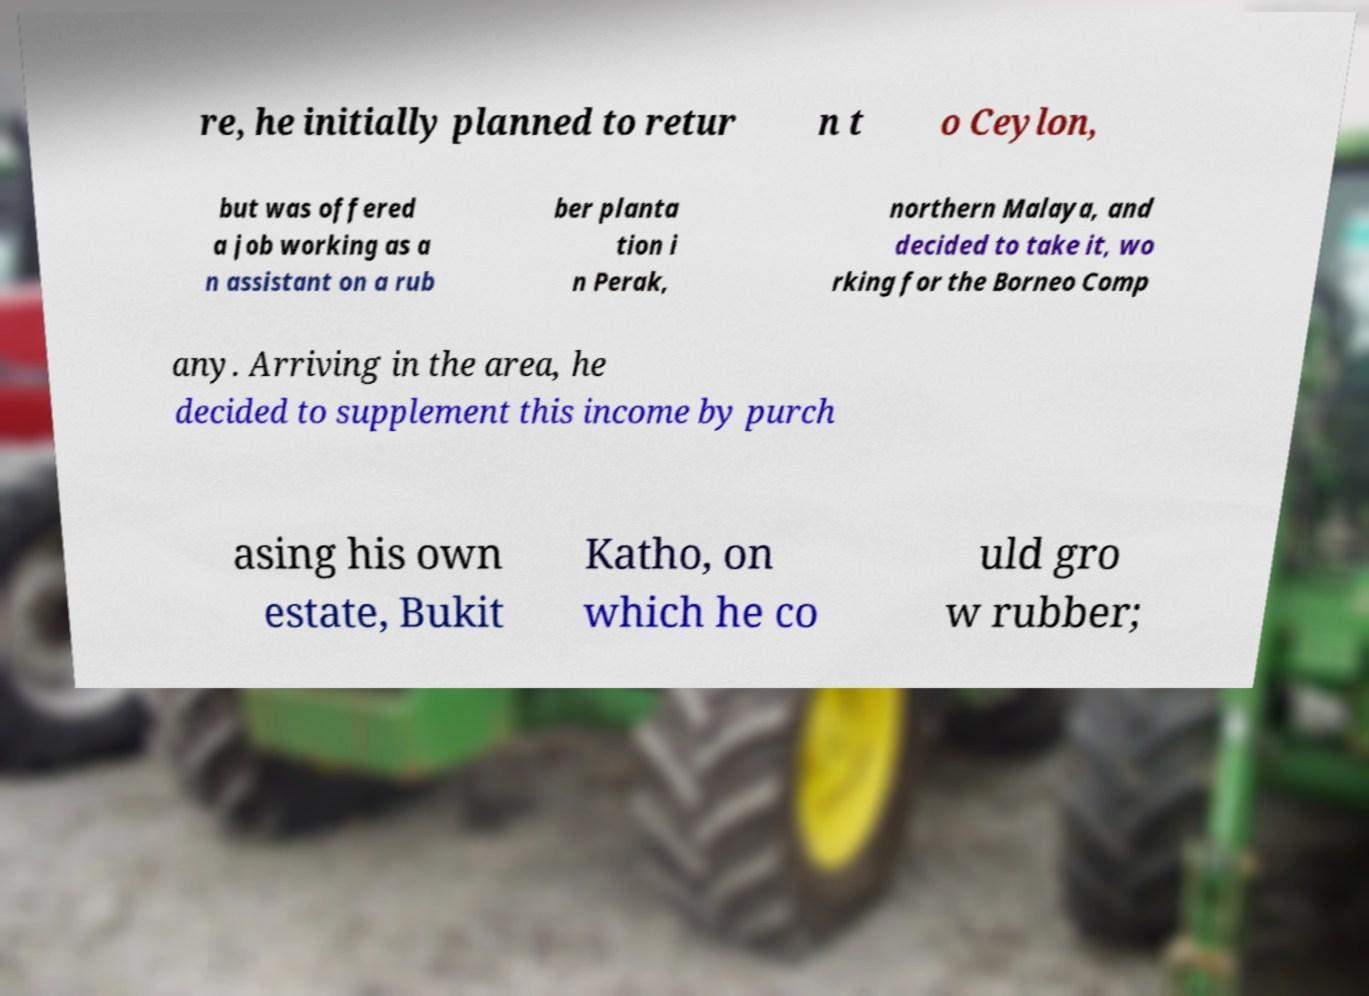Please read and relay the text visible in this image. What does it say? re, he initially planned to retur n t o Ceylon, but was offered a job working as a n assistant on a rub ber planta tion i n Perak, northern Malaya, and decided to take it, wo rking for the Borneo Comp any. Arriving in the area, he decided to supplement this income by purch asing his own estate, Bukit Katho, on which he co uld gro w rubber; 